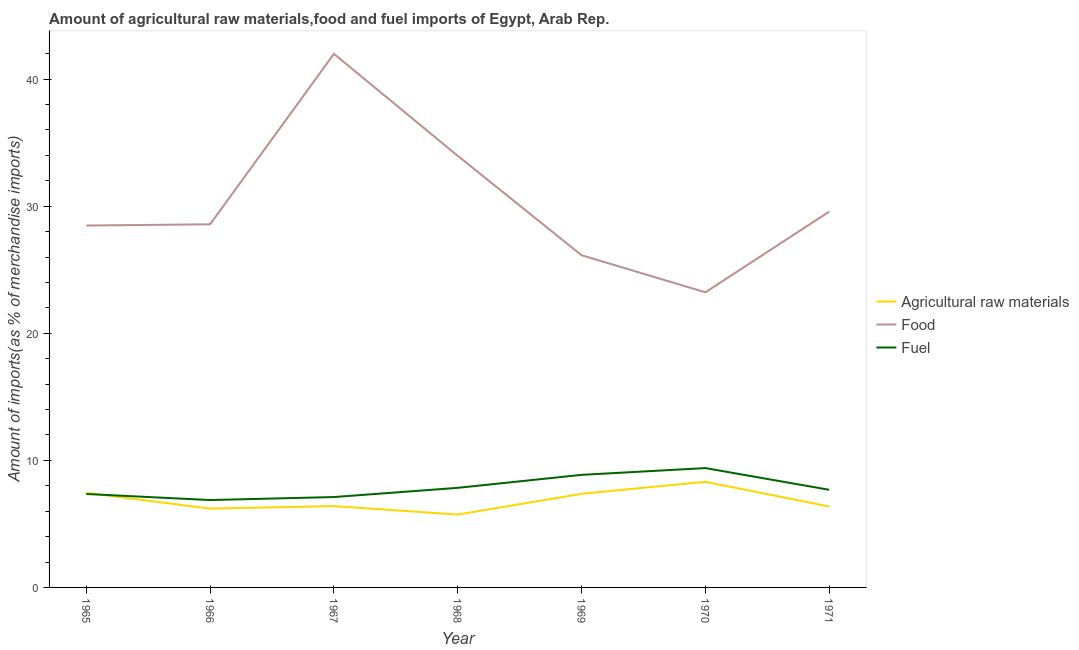How many different coloured lines are there?
Offer a terse response. 3. What is the percentage of fuel imports in 1969?
Provide a short and direct response. 8.86. Across all years, what is the maximum percentage of fuel imports?
Ensure brevity in your answer.  9.39. Across all years, what is the minimum percentage of raw materials imports?
Offer a terse response. 5.73. In which year was the percentage of raw materials imports minimum?
Ensure brevity in your answer.  1968. What is the total percentage of raw materials imports in the graph?
Provide a short and direct response. 47.83. What is the difference between the percentage of raw materials imports in 1966 and that in 1967?
Keep it short and to the point. -0.2. What is the difference between the percentage of raw materials imports in 1971 and the percentage of fuel imports in 1968?
Provide a succinct answer. -1.47. What is the average percentage of raw materials imports per year?
Keep it short and to the point. 6.83. In the year 1968, what is the difference between the percentage of food imports and percentage of raw materials imports?
Ensure brevity in your answer.  28.23. What is the ratio of the percentage of food imports in 1966 to that in 1968?
Give a very brief answer. 0.84. Is the difference between the percentage of raw materials imports in 1967 and 1970 greater than the difference between the percentage of fuel imports in 1967 and 1970?
Provide a succinct answer. Yes. What is the difference between the highest and the second highest percentage of food imports?
Make the answer very short. 8.03. What is the difference between the highest and the lowest percentage of fuel imports?
Give a very brief answer. 2.51. In how many years, is the percentage of food imports greater than the average percentage of food imports taken over all years?
Your answer should be very brief. 2. Is it the case that in every year, the sum of the percentage of raw materials imports and percentage of food imports is greater than the percentage of fuel imports?
Give a very brief answer. Yes. Does the percentage of fuel imports monotonically increase over the years?
Offer a terse response. No. Is the percentage of food imports strictly greater than the percentage of fuel imports over the years?
Your response must be concise. Yes. Is the percentage of fuel imports strictly less than the percentage of food imports over the years?
Your answer should be compact. Yes. How many lines are there?
Keep it short and to the point. 3. What is the difference between two consecutive major ticks on the Y-axis?
Your response must be concise. 10. Are the values on the major ticks of Y-axis written in scientific E-notation?
Give a very brief answer. No. Does the graph contain any zero values?
Make the answer very short. No. How many legend labels are there?
Offer a very short reply. 3. What is the title of the graph?
Ensure brevity in your answer.  Amount of agricultural raw materials,food and fuel imports of Egypt, Arab Rep. Does "Social Protection and Labor" appear as one of the legend labels in the graph?
Your answer should be very brief. No. What is the label or title of the X-axis?
Offer a very short reply. Year. What is the label or title of the Y-axis?
Your answer should be very brief. Amount of imports(as % of merchandise imports). What is the Amount of imports(as % of merchandise imports) of Agricultural raw materials in 1965?
Your response must be concise. 7.44. What is the Amount of imports(as % of merchandise imports) in Food in 1965?
Your response must be concise. 28.48. What is the Amount of imports(as % of merchandise imports) of Fuel in 1965?
Offer a very short reply. 7.35. What is the Amount of imports(as % of merchandise imports) in Agricultural raw materials in 1966?
Your response must be concise. 6.2. What is the Amount of imports(as % of merchandise imports) in Food in 1966?
Your answer should be very brief. 28.58. What is the Amount of imports(as % of merchandise imports) of Fuel in 1966?
Offer a terse response. 6.88. What is the Amount of imports(as % of merchandise imports) in Agricultural raw materials in 1967?
Make the answer very short. 6.4. What is the Amount of imports(as % of merchandise imports) in Food in 1967?
Provide a succinct answer. 41.99. What is the Amount of imports(as % of merchandise imports) of Fuel in 1967?
Provide a succinct answer. 7.11. What is the Amount of imports(as % of merchandise imports) in Agricultural raw materials in 1968?
Make the answer very short. 5.73. What is the Amount of imports(as % of merchandise imports) in Food in 1968?
Your answer should be compact. 33.96. What is the Amount of imports(as % of merchandise imports) of Fuel in 1968?
Keep it short and to the point. 7.84. What is the Amount of imports(as % of merchandise imports) of Agricultural raw materials in 1969?
Your response must be concise. 7.37. What is the Amount of imports(as % of merchandise imports) of Food in 1969?
Keep it short and to the point. 26.14. What is the Amount of imports(as % of merchandise imports) in Fuel in 1969?
Offer a very short reply. 8.86. What is the Amount of imports(as % of merchandise imports) in Agricultural raw materials in 1970?
Keep it short and to the point. 8.31. What is the Amount of imports(as % of merchandise imports) in Food in 1970?
Give a very brief answer. 23.22. What is the Amount of imports(as % of merchandise imports) in Fuel in 1970?
Make the answer very short. 9.39. What is the Amount of imports(as % of merchandise imports) of Agricultural raw materials in 1971?
Offer a very short reply. 6.37. What is the Amount of imports(as % of merchandise imports) of Food in 1971?
Your answer should be very brief. 29.57. What is the Amount of imports(as % of merchandise imports) of Fuel in 1971?
Provide a succinct answer. 7.68. Across all years, what is the maximum Amount of imports(as % of merchandise imports) of Agricultural raw materials?
Provide a succinct answer. 8.31. Across all years, what is the maximum Amount of imports(as % of merchandise imports) of Food?
Provide a short and direct response. 41.99. Across all years, what is the maximum Amount of imports(as % of merchandise imports) in Fuel?
Give a very brief answer. 9.39. Across all years, what is the minimum Amount of imports(as % of merchandise imports) of Agricultural raw materials?
Your response must be concise. 5.73. Across all years, what is the minimum Amount of imports(as % of merchandise imports) in Food?
Provide a short and direct response. 23.22. Across all years, what is the minimum Amount of imports(as % of merchandise imports) of Fuel?
Offer a terse response. 6.88. What is the total Amount of imports(as % of merchandise imports) in Agricultural raw materials in the graph?
Provide a short and direct response. 47.83. What is the total Amount of imports(as % of merchandise imports) of Food in the graph?
Give a very brief answer. 211.94. What is the total Amount of imports(as % of merchandise imports) of Fuel in the graph?
Ensure brevity in your answer.  55.11. What is the difference between the Amount of imports(as % of merchandise imports) in Agricultural raw materials in 1965 and that in 1966?
Offer a terse response. 1.24. What is the difference between the Amount of imports(as % of merchandise imports) in Food in 1965 and that in 1966?
Keep it short and to the point. -0.1. What is the difference between the Amount of imports(as % of merchandise imports) of Fuel in 1965 and that in 1966?
Ensure brevity in your answer.  0.48. What is the difference between the Amount of imports(as % of merchandise imports) of Agricultural raw materials in 1965 and that in 1967?
Ensure brevity in your answer.  1.04. What is the difference between the Amount of imports(as % of merchandise imports) in Food in 1965 and that in 1967?
Make the answer very short. -13.51. What is the difference between the Amount of imports(as % of merchandise imports) of Fuel in 1965 and that in 1967?
Offer a terse response. 0.24. What is the difference between the Amount of imports(as % of merchandise imports) in Agricultural raw materials in 1965 and that in 1968?
Provide a short and direct response. 1.71. What is the difference between the Amount of imports(as % of merchandise imports) in Food in 1965 and that in 1968?
Your response must be concise. -5.48. What is the difference between the Amount of imports(as % of merchandise imports) of Fuel in 1965 and that in 1968?
Provide a succinct answer. -0.48. What is the difference between the Amount of imports(as % of merchandise imports) of Agricultural raw materials in 1965 and that in 1969?
Your answer should be very brief. 0.08. What is the difference between the Amount of imports(as % of merchandise imports) of Food in 1965 and that in 1969?
Offer a terse response. 2.34. What is the difference between the Amount of imports(as % of merchandise imports) of Fuel in 1965 and that in 1969?
Your answer should be compact. -1.51. What is the difference between the Amount of imports(as % of merchandise imports) of Agricultural raw materials in 1965 and that in 1970?
Provide a succinct answer. -0.87. What is the difference between the Amount of imports(as % of merchandise imports) of Food in 1965 and that in 1970?
Offer a very short reply. 5.25. What is the difference between the Amount of imports(as % of merchandise imports) of Fuel in 1965 and that in 1970?
Make the answer very short. -2.04. What is the difference between the Amount of imports(as % of merchandise imports) in Agricultural raw materials in 1965 and that in 1971?
Offer a terse response. 1.07. What is the difference between the Amount of imports(as % of merchandise imports) in Food in 1965 and that in 1971?
Offer a very short reply. -1.1. What is the difference between the Amount of imports(as % of merchandise imports) of Fuel in 1965 and that in 1971?
Offer a terse response. -0.33. What is the difference between the Amount of imports(as % of merchandise imports) in Agricultural raw materials in 1966 and that in 1967?
Your response must be concise. -0.2. What is the difference between the Amount of imports(as % of merchandise imports) of Food in 1966 and that in 1967?
Provide a short and direct response. -13.41. What is the difference between the Amount of imports(as % of merchandise imports) in Fuel in 1966 and that in 1967?
Your response must be concise. -0.24. What is the difference between the Amount of imports(as % of merchandise imports) of Agricultural raw materials in 1966 and that in 1968?
Your response must be concise. 0.47. What is the difference between the Amount of imports(as % of merchandise imports) in Food in 1966 and that in 1968?
Keep it short and to the point. -5.39. What is the difference between the Amount of imports(as % of merchandise imports) of Fuel in 1966 and that in 1968?
Ensure brevity in your answer.  -0.96. What is the difference between the Amount of imports(as % of merchandise imports) of Agricultural raw materials in 1966 and that in 1969?
Make the answer very short. -1.16. What is the difference between the Amount of imports(as % of merchandise imports) of Food in 1966 and that in 1969?
Ensure brevity in your answer.  2.43. What is the difference between the Amount of imports(as % of merchandise imports) of Fuel in 1966 and that in 1969?
Keep it short and to the point. -1.98. What is the difference between the Amount of imports(as % of merchandise imports) of Agricultural raw materials in 1966 and that in 1970?
Offer a very short reply. -2.11. What is the difference between the Amount of imports(as % of merchandise imports) of Food in 1966 and that in 1970?
Your response must be concise. 5.35. What is the difference between the Amount of imports(as % of merchandise imports) of Fuel in 1966 and that in 1970?
Offer a terse response. -2.51. What is the difference between the Amount of imports(as % of merchandise imports) of Agricultural raw materials in 1966 and that in 1971?
Make the answer very short. -0.17. What is the difference between the Amount of imports(as % of merchandise imports) in Food in 1966 and that in 1971?
Provide a succinct answer. -1. What is the difference between the Amount of imports(as % of merchandise imports) of Fuel in 1966 and that in 1971?
Give a very brief answer. -0.81. What is the difference between the Amount of imports(as % of merchandise imports) in Agricultural raw materials in 1967 and that in 1968?
Your response must be concise. 0.67. What is the difference between the Amount of imports(as % of merchandise imports) in Food in 1967 and that in 1968?
Give a very brief answer. 8.03. What is the difference between the Amount of imports(as % of merchandise imports) in Fuel in 1967 and that in 1968?
Provide a short and direct response. -0.72. What is the difference between the Amount of imports(as % of merchandise imports) in Agricultural raw materials in 1967 and that in 1969?
Provide a succinct answer. -0.97. What is the difference between the Amount of imports(as % of merchandise imports) of Food in 1967 and that in 1969?
Keep it short and to the point. 15.85. What is the difference between the Amount of imports(as % of merchandise imports) of Fuel in 1967 and that in 1969?
Your answer should be compact. -1.75. What is the difference between the Amount of imports(as % of merchandise imports) in Agricultural raw materials in 1967 and that in 1970?
Provide a succinct answer. -1.91. What is the difference between the Amount of imports(as % of merchandise imports) of Food in 1967 and that in 1970?
Your answer should be very brief. 18.76. What is the difference between the Amount of imports(as % of merchandise imports) in Fuel in 1967 and that in 1970?
Your response must be concise. -2.28. What is the difference between the Amount of imports(as % of merchandise imports) in Agricultural raw materials in 1967 and that in 1971?
Keep it short and to the point. 0.03. What is the difference between the Amount of imports(as % of merchandise imports) of Food in 1967 and that in 1971?
Keep it short and to the point. 12.41. What is the difference between the Amount of imports(as % of merchandise imports) of Fuel in 1967 and that in 1971?
Make the answer very short. -0.57. What is the difference between the Amount of imports(as % of merchandise imports) in Agricultural raw materials in 1968 and that in 1969?
Provide a succinct answer. -1.63. What is the difference between the Amount of imports(as % of merchandise imports) in Food in 1968 and that in 1969?
Provide a short and direct response. 7.82. What is the difference between the Amount of imports(as % of merchandise imports) of Fuel in 1968 and that in 1969?
Your response must be concise. -1.02. What is the difference between the Amount of imports(as % of merchandise imports) in Agricultural raw materials in 1968 and that in 1970?
Ensure brevity in your answer.  -2.58. What is the difference between the Amount of imports(as % of merchandise imports) of Food in 1968 and that in 1970?
Give a very brief answer. 10.74. What is the difference between the Amount of imports(as % of merchandise imports) of Fuel in 1968 and that in 1970?
Your answer should be compact. -1.55. What is the difference between the Amount of imports(as % of merchandise imports) of Agricultural raw materials in 1968 and that in 1971?
Offer a very short reply. -0.64. What is the difference between the Amount of imports(as % of merchandise imports) of Food in 1968 and that in 1971?
Provide a succinct answer. 4.39. What is the difference between the Amount of imports(as % of merchandise imports) in Fuel in 1968 and that in 1971?
Keep it short and to the point. 0.15. What is the difference between the Amount of imports(as % of merchandise imports) of Agricultural raw materials in 1969 and that in 1970?
Provide a succinct answer. -0.95. What is the difference between the Amount of imports(as % of merchandise imports) of Food in 1969 and that in 1970?
Provide a succinct answer. 2.92. What is the difference between the Amount of imports(as % of merchandise imports) in Fuel in 1969 and that in 1970?
Ensure brevity in your answer.  -0.53. What is the difference between the Amount of imports(as % of merchandise imports) in Food in 1969 and that in 1971?
Keep it short and to the point. -3.43. What is the difference between the Amount of imports(as % of merchandise imports) of Fuel in 1969 and that in 1971?
Your answer should be very brief. 1.18. What is the difference between the Amount of imports(as % of merchandise imports) in Agricultural raw materials in 1970 and that in 1971?
Ensure brevity in your answer.  1.94. What is the difference between the Amount of imports(as % of merchandise imports) in Food in 1970 and that in 1971?
Keep it short and to the point. -6.35. What is the difference between the Amount of imports(as % of merchandise imports) of Fuel in 1970 and that in 1971?
Your answer should be compact. 1.71. What is the difference between the Amount of imports(as % of merchandise imports) of Agricultural raw materials in 1965 and the Amount of imports(as % of merchandise imports) of Food in 1966?
Provide a succinct answer. -21.13. What is the difference between the Amount of imports(as % of merchandise imports) of Agricultural raw materials in 1965 and the Amount of imports(as % of merchandise imports) of Fuel in 1966?
Offer a terse response. 0.57. What is the difference between the Amount of imports(as % of merchandise imports) in Food in 1965 and the Amount of imports(as % of merchandise imports) in Fuel in 1966?
Give a very brief answer. 21.6. What is the difference between the Amount of imports(as % of merchandise imports) of Agricultural raw materials in 1965 and the Amount of imports(as % of merchandise imports) of Food in 1967?
Make the answer very short. -34.55. What is the difference between the Amount of imports(as % of merchandise imports) in Agricultural raw materials in 1965 and the Amount of imports(as % of merchandise imports) in Fuel in 1967?
Keep it short and to the point. 0.33. What is the difference between the Amount of imports(as % of merchandise imports) in Food in 1965 and the Amount of imports(as % of merchandise imports) in Fuel in 1967?
Your response must be concise. 21.36. What is the difference between the Amount of imports(as % of merchandise imports) of Agricultural raw materials in 1965 and the Amount of imports(as % of merchandise imports) of Food in 1968?
Offer a very short reply. -26.52. What is the difference between the Amount of imports(as % of merchandise imports) of Agricultural raw materials in 1965 and the Amount of imports(as % of merchandise imports) of Fuel in 1968?
Your answer should be compact. -0.39. What is the difference between the Amount of imports(as % of merchandise imports) in Food in 1965 and the Amount of imports(as % of merchandise imports) in Fuel in 1968?
Provide a succinct answer. 20.64. What is the difference between the Amount of imports(as % of merchandise imports) of Agricultural raw materials in 1965 and the Amount of imports(as % of merchandise imports) of Food in 1969?
Provide a short and direct response. -18.7. What is the difference between the Amount of imports(as % of merchandise imports) of Agricultural raw materials in 1965 and the Amount of imports(as % of merchandise imports) of Fuel in 1969?
Ensure brevity in your answer.  -1.42. What is the difference between the Amount of imports(as % of merchandise imports) of Food in 1965 and the Amount of imports(as % of merchandise imports) of Fuel in 1969?
Offer a terse response. 19.62. What is the difference between the Amount of imports(as % of merchandise imports) of Agricultural raw materials in 1965 and the Amount of imports(as % of merchandise imports) of Food in 1970?
Ensure brevity in your answer.  -15.78. What is the difference between the Amount of imports(as % of merchandise imports) in Agricultural raw materials in 1965 and the Amount of imports(as % of merchandise imports) in Fuel in 1970?
Your answer should be very brief. -1.95. What is the difference between the Amount of imports(as % of merchandise imports) of Food in 1965 and the Amount of imports(as % of merchandise imports) of Fuel in 1970?
Your answer should be very brief. 19.09. What is the difference between the Amount of imports(as % of merchandise imports) of Agricultural raw materials in 1965 and the Amount of imports(as % of merchandise imports) of Food in 1971?
Your answer should be very brief. -22.13. What is the difference between the Amount of imports(as % of merchandise imports) in Agricultural raw materials in 1965 and the Amount of imports(as % of merchandise imports) in Fuel in 1971?
Give a very brief answer. -0.24. What is the difference between the Amount of imports(as % of merchandise imports) in Food in 1965 and the Amount of imports(as % of merchandise imports) in Fuel in 1971?
Provide a short and direct response. 20.8. What is the difference between the Amount of imports(as % of merchandise imports) of Agricultural raw materials in 1966 and the Amount of imports(as % of merchandise imports) of Food in 1967?
Offer a terse response. -35.79. What is the difference between the Amount of imports(as % of merchandise imports) in Agricultural raw materials in 1966 and the Amount of imports(as % of merchandise imports) in Fuel in 1967?
Make the answer very short. -0.91. What is the difference between the Amount of imports(as % of merchandise imports) of Food in 1966 and the Amount of imports(as % of merchandise imports) of Fuel in 1967?
Ensure brevity in your answer.  21.46. What is the difference between the Amount of imports(as % of merchandise imports) in Agricultural raw materials in 1966 and the Amount of imports(as % of merchandise imports) in Food in 1968?
Your response must be concise. -27.76. What is the difference between the Amount of imports(as % of merchandise imports) of Agricultural raw materials in 1966 and the Amount of imports(as % of merchandise imports) of Fuel in 1968?
Your answer should be very brief. -1.63. What is the difference between the Amount of imports(as % of merchandise imports) in Food in 1966 and the Amount of imports(as % of merchandise imports) in Fuel in 1968?
Provide a short and direct response. 20.74. What is the difference between the Amount of imports(as % of merchandise imports) in Agricultural raw materials in 1966 and the Amount of imports(as % of merchandise imports) in Food in 1969?
Give a very brief answer. -19.94. What is the difference between the Amount of imports(as % of merchandise imports) of Agricultural raw materials in 1966 and the Amount of imports(as % of merchandise imports) of Fuel in 1969?
Provide a succinct answer. -2.66. What is the difference between the Amount of imports(as % of merchandise imports) in Food in 1966 and the Amount of imports(as % of merchandise imports) in Fuel in 1969?
Your answer should be very brief. 19.72. What is the difference between the Amount of imports(as % of merchandise imports) of Agricultural raw materials in 1966 and the Amount of imports(as % of merchandise imports) of Food in 1970?
Offer a very short reply. -17.02. What is the difference between the Amount of imports(as % of merchandise imports) of Agricultural raw materials in 1966 and the Amount of imports(as % of merchandise imports) of Fuel in 1970?
Give a very brief answer. -3.19. What is the difference between the Amount of imports(as % of merchandise imports) in Food in 1966 and the Amount of imports(as % of merchandise imports) in Fuel in 1970?
Give a very brief answer. 19.19. What is the difference between the Amount of imports(as % of merchandise imports) of Agricultural raw materials in 1966 and the Amount of imports(as % of merchandise imports) of Food in 1971?
Ensure brevity in your answer.  -23.37. What is the difference between the Amount of imports(as % of merchandise imports) of Agricultural raw materials in 1966 and the Amount of imports(as % of merchandise imports) of Fuel in 1971?
Provide a short and direct response. -1.48. What is the difference between the Amount of imports(as % of merchandise imports) in Food in 1966 and the Amount of imports(as % of merchandise imports) in Fuel in 1971?
Ensure brevity in your answer.  20.89. What is the difference between the Amount of imports(as % of merchandise imports) of Agricultural raw materials in 1967 and the Amount of imports(as % of merchandise imports) of Food in 1968?
Make the answer very short. -27.56. What is the difference between the Amount of imports(as % of merchandise imports) in Agricultural raw materials in 1967 and the Amount of imports(as % of merchandise imports) in Fuel in 1968?
Keep it short and to the point. -1.44. What is the difference between the Amount of imports(as % of merchandise imports) of Food in 1967 and the Amount of imports(as % of merchandise imports) of Fuel in 1968?
Keep it short and to the point. 34.15. What is the difference between the Amount of imports(as % of merchandise imports) of Agricultural raw materials in 1967 and the Amount of imports(as % of merchandise imports) of Food in 1969?
Your answer should be compact. -19.74. What is the difference between the Amount of imports(as % of merchandise imports) of Agricultural raw materials in 1967 and the Amount of imports(as % of merchandise imports) of Fuel in 1969?
Offer a very short reply. -2.46. What is the difference between the Amount of imports(as % of merchandise imports) in Food in 1967 and the Amount of imports(as % of merchandise imports) in Fuel in 1969?
Offer a very short reply. 33.13. What is the difference between the Amount of imports(as % of merchandise imports) in Agricultural raw materials in 1967 and the Amount of imports(as % of merchandise imports) in Food in 1970?
Offer a terse response. -16.82. What is the difference between the Amount of imports(as % of merchandise imports) in Agricultural raw materials in 1967 and the Amount of imports(as % of merchandise imports) in Fuel in 1970?
Make the answer very short. -2.99. What is the difference between the Amount of imports(as % of merchandise imports) in Food in 1967 and the Amount of imports(as % of merchandise imports) in Fuel in 1970?
Your answer should be very brief. 32.6. What is the difference between the Amount of imports(as % of merchandise imports) of Agricultural raw materials in 1967 and the Amount of imports(as % of merchandise imports) of Food in 1971?
Your response must be concise. -23.17. What is the difference between the Amount of imports(as % of merchandise imports) in Agricultural raw materials in 1967 and the Amount of imports(as % of merchandise imports) in Fuel in 1971?
Keep it short and to the point. -1.28. What is the difference between the Amount of imports(as % of merchandise imports) of Food in 1967 and the Amount of imports(as % of merchandise imports) of Fuel in 1971?
Make the answer very short. 34.31. What is the difference between the Amount of imports(as % of merchandise imports) of Agricultural raw materials in 1968 and the Amount of imports(as % of merchandise imports) of Food in 1969?
Offer a terse response. -20.41. What is the difference between the Amount of imports(as % of merchandise imports) of Agricultural raw materials in 1968 and the Amount of imports(as % of merchandise imports) of Fuel in 1969?
Offer a very short reply. -3.13. What is the difference between the Amount of imports(as % of merchandise imports) in Food in 1968 and the Amount of imports(as % of merchandise imports) in Fuel in 1969?
Give a very brief answer. 25.1. What is the difference between the Amount of imports(as % of merchandise imports) of Agricultural raw materials in 1968 and the Amount of imports(as % of merchandise imports) of Food in 1970?
Offer a terse response. -17.49. What is the difference between the Amount of imports(as % of merchandise imports) in Agricultural raw materials in 1968 and the Amount of imports(as % of merchandise imports) in Fuel in 1970?
Your answer should be very brief. -3.66. What is the difference between the Amount of imports(as % of merchandise imports) of Food in 1968 and the Amount of imports(as % of merchandise imports) of Fuel in 1970?
Provide a short and direct response. 24.57. What is the difference between the Amount of imports(as % of merchandise imports) of Agricultural raw materials in 1968 and the Amount of imports(as % of merchandise imports) of Food in 1971?
Give a very brief answer. -23.84. What is the difference between the Amount of imports(as % of merchandise imports) in Agricultural raw materials in 1968 and the Amount of imports(as % of merchandise imports) in Fuel in 1971?
Ensure brevity in your answer.  -1.95. What is the difference between the Amount of imports(as % of merchandise imports) of Food in 1968 and the Amount of imports(as % of merchandise imports) of Fuel in 1971?
Offer a very short reply. 26.28. What is the difference between the Amount of imports(as % of merchandise imports) in Agricultural raw materials in 1969 and the Amount of imports(as % of merchandise imports) in Food in 1970?
Offer a terse response. -15.86. What is the difference between the Amount of imports(as % of merchandise imports) in Agricultural raw materials in 1969 and the Amount of imports(as % of merchandise imports) in Fuel in 1970?
Make the answer very short. -2.02. What is the difference between the Amount of imports(as % of merchandise imports) of Food in 1969 and the Amount of imports(as % of merchandise imports) of Fuel in 1970?
Make the answer very short. 16.75. What is the difference between the Amount of imports(as % of merchandise imports) of Agricultural raw materials in 1969 and the Amount of imports(as % of merchandise imports) of Food in 1971?
Ensure brevity in your answer.  -22.21. What is the difference between the Amount of imports(as % of merchandise imports) in Agricultural raw materials in 1969 and the Amount of imports(as % of merchandise imports) in Fuel in 1971?
Your response must be concise. -0.32. What is the difference between the Amount of imports(as % of merchandise imports) of Food in 1969 and the Amount of imports(as % of merchandise imports) of Fuel in 1971?
Give a very brief answer. 18.46. What is the difference between the Amount of imports(as % of merchandise imports) of Agricultural raw materials in 1970 and the Amount of imports(as % of merchandise imports) of Food in 1971?
Ensure brevity in your answer.  -21.26. What is the difference between the Amount of imports(as % of merchandise imports) of Agricultural raw materials in 1970 and the Amount of imports(as % of merchandise imports) of Fuel in 1971?
Give a very brief answer. 0.63. What is the difference between the Amount of imports(as % of merchandise imports) in Food in 1970 and the Amount of imports(as % of merchandise imports) in Fuel in 1971?
Your response must be concise. 15.54. What is the average Amount of imports(as % of merchandise imports) in Agricultural raw materials per year?
Your answer should be very brief. 6.83. What is the average Amount of imports(as % of merchandise imports) in Food per year?
Give a very brief answer. 30.28. What is the average Amount of imports(as % of merchandise imports) in Fuel per year?
Offer a terse response. 7.87. In the year 1965, what is the difference between the Amount of imports(as % of merchandise imports) in Agricultural raw materials and Amount of imports(as % of merchandise imports) in Food?
Provide a short and direct response. -21.04. In the year 1965, what is the difference between the Amount of imports(as % of merchandise imports) in Agricultural raw materials and Amount of imports(as % of merchandise imports) in Fuel?
Your answer should be compact. 0.09. In the year 1965, what is the difference between the Amount of imports(as % of merchandise imports) of Food and Amount of imports(as % of merchandise imports) of Fuel?
Your response must be concise. 21.13. In the year 1966, what is the difference between the Amount of imports(as % of merchandise imports) in Agricultural raw materials and Amount of imports(as % of merchandise imports) in Food?
Offer a very short reply. -22.37. In the year 1966, what is the difference between the Amount of imports(as % of merchandise imports) of Agricultural raw materials and Amount of imports(as % of merchandise imports) of Fuel?
Keep it short and to the point. -0.67. In the year 1966, what is the difference between the Amount of imports(as % of merchandise imports) of Food and Amount of imports(as % of merchandise imports) of Fuel?
Your response must be concise. 21.7. In the year 1967, what is the difference between the Amount of imports(as % of merchandise imports) in Agricultural raw materials and Amount of imports(as % of merchandise imports) in Food?
Provide a succinct answer. -35.59. In the year 1967, what is the difference between the Amount of imports(as % of merchandise imports) in Agricultural raw materials and Amount of imports(as % of merchandise imports) in Fuel?
Offer a very short reply. -0.71. In the year 1967, what is the difference between the Amount of imports(as % of merchandise imports) in Food and Amount of imports(as % of merchandise imports) in Fuel?
Keep it short and to the point. 34.88. In the year 1968, what is the difference between the Amount of imports(as % of merchandise imports) in Agricultural raw materials and Amount of imports(as % of merchandise imports) in Food?
Your response must be concise. -28.23. In the year 1968, what is the difference between the Amount of imports(as % of merchandise imports) of Agricultural raw materials and Amount of imports(as % of merchandise imports) of Fuel?
Provide a short and direct response. -2.1. In the year 1968, what is the difference between the Amount of imports(as % of merchandise imports) of Food and Amount of imports(as % of merchandise imports) of Fuel?
Your answer should be very brief. 26.13. In the year 1969, what is the difference between the Amount of imports(as % of merchandise imports) of Agricultural raw materials and Amount of imports(as % of merchandise imports) of Food?
Your answer should be very brief. -18.78. In the year 1969, what is the difference between the Amount of imports(as % of merchandise imports) in Agricultural raw materials and Amount of imports(as % of merchandise imports) in Fuel?
Make the answer very short. -1.49. In the year 1969, what is the difference between the Amount of imports(as % of merchandise imports) of Food and Amount of imports(as % of merchandise imports) of Fuel?
Give a very brief answer. 17.28. In the year 1970, what is the difference between the Amount of imports(as % of merchandise imports) of Agricultural raw materials and Amount of imports(as % of merchandise imports) of Food?
Keep it short and to the point. -14.91. In the year 1970, what is the difference between the Amount of imports(as % of merchandise imports) of Agricultural raw materials and Amount of imports(as % of merchandise imports) of Fuel?
Give a very brief answer. -1.08. In the year 1970, what is the difference between the Amount of imports(as % of merchandise imports) in Food and Amount of imports(as % of merchandise imports) in Fuel?
Keep it short and to the point. 13.83. In the year 1971, what is the difference between the Amount of imports(as % of merchandise imports) of Agricultural raw materials and Amount of imports(as % of merchandise imports) of Food?
Your answer should be very brief. -23.2. In the year 1971, what is the difference between the Amount of imports(as % of merchandise imports) of Agricultural raw materials and Amount of imports(as % of merchandise imports) of Fuel?
Offer a very short reply. -1.31. In the year 1971, what is the difference between the Amount of imports(as % of merchandise imports) in Food and Amount of imports(as % of merchandise imports) in Fuel?
Offer a terse response. 21.89. What is the ratio of the Amount of imports(as % of merchandise imports) in Agricultural raw materials in 1965 to that in 1966?
Give a very brief answer. 1.2. What is the ratio of the Amount of imports(as % of merchandise imports) in Fuel in 1965 to that in 1966?
Ensure brevity in your answer.  1.07. What is the ratio of the Amount of imports(as % of merchandise imports) in Agricultural raw materials in 1965 to that in 1967?
Your answer should be very brief. 1.16. What is the ratio of the Amount of imports(as % of merchandise imports) of Food in 1965 to that in 1967?
Provide a succinct answer. 0.68. What is the ratio of the Amount of imports(as % of merchandise imports) of Fuel in 1965 to that in 1967?
Your answer should be very brief. 1.03. What is the ratio of the Amount of imports(as % of merchandise imports) in Agricultural raw materials in 1965 to that in 1968?
Provide a succinct answer. 1.3. What is the ratio of the Amount of imports(as % of merchandise imports) in Food in 1965 to that in 1968?
Offer a terse response. 0.84. What is the ratio of the Amount of imports(as % of merchandise imports) in Fuel in 1965 to that in 1968?
Your response must be concise. 0.94. What is the ratio of the Amount of imports(as % of merchandise imports) in Agricultural raw materials in 1965 to that in 1969?
Your response must be concise. 1.01. What is the ratio of the Amount of imports(as % of merchandise imports) of Food in 1965 to that in 1969?
Offer a terse response. 1.09. What is the ratio of the Amount of imports(as % of merchandise imports) of Fuel in 1965 to that in 1969?
Offer a terse response. 0.83. What is the ratio of the Amount of imports(as % of merchandise imports) in Agricultural raw materials in 1965 to that in 1970?
Your answer should be very brief. 0.9. What is the ratio of the Amount of imports(as % of merchandise imports) of Food in 1965 to that in 1970?
Keep it short and to the point. 1.23. What is the ratio of the Amount of imports(as % of merchandise imports) of Fuel in 1965 to that in 1970?
Provide a short and direct response. 0.78. What is the ratio of the Amount of imports(as % of merchandise imports) in Agricultural raw materials in 1965 to that in 1971?
Ensure brevity in your answer.  1.17. What is the ratio of the Amount of imports(as % of merchandise imports) in Food in 1965 to that in 1971?
Make the answer very short. 0.96. What is the ratio of the Amount of imports(as % of merchandise imports) of Fuel in 1965 to that in 1971?
Give a very brief answer. 0.96. What is the ratio of the Amount of imports(as % of merchandise imports) in Agricultural raw materials in 1966 to that in 1967?
Ensure brevity in your answer.  0.97. What is the ratio of the Amount of imports(as % of merchandise imports) in Food in 1966 to that in 1967?
Make the answer very short. 0.68. What is the ratio of the Amount of imports(as % of merchandise imports) in Fuel in 1966 to that in 1967?
Your response must be concise. 0.97. What is the ratio of the Amount of imports(as % of merchandise imports) in Agricultural raw materials in 1966 to that in 1968?
Give a very brief answer. 1.08. What is the ratio of the Amount of imports(as % of merchandise imports) of Food in 1966 to that in 1968?
Your answer should be very brief. 0.84. What is the ratio of the Amount of imports(as % of merchandise imports) in Fuel in 1966 to that in 1968?
Provide a short and direct response. 0.88. What is the ratio of the Amount of imports(as % of merchandise imports) in Agricultural raw materials in 1966 to that in 1969?
Ensure brevity in your answer.  0.84. What is the ratio of the Amount of imports(as % of merchandise imports) in Food in 1966 to that in 1969?
Offer a terse response. 1.09. What is the ratio of the Amount of imports(as % of merchandise imports) of Fuel in 1966 to that in 1969?
Provide a succinct answer. 0.78. What is the ratio of the Amount of imports(as % of merchandise imports) of Agricultural raw materials in 1966 to that in 1970?
Offer a very short reply. 0.75. What is the ratio of the Amount of imports(as % of merchandise imports) in Food in 1966 to that in 1970?
Give a very brief answer. 1.23. What is the ratio of the Amount of imports(as % of merchandise imports) of Fuel in 1966 to that in 1970?
Your answer should be very brief. 0.73. What is the ratio of the Amount of imports(as % of merchandise imports) of Agricultural raw materials in 1966 to that in 1971?
Provide a succinct answer. 0.97. What is the ratio of the Amount of imports(as % of merchandise imports) of Food in 1966 to that in 1971?
Offer a terse response. 0.97. What is the ratio of the Amount of imports(as % of merchandise imports) of Fuel in 1966 to that in 1971?
Your response must be concise. 0.9. What is the ratio of the Amount of imports(as % of merchandise imports) of Agricultural raw materials in 1967 to that in 1968?
Your response must be concise. 1.12. What is the ratio of the Amount of imports(as % of merchandise imports) in Food in 1967 to that in 1968?
Provide a short and direct response. 1.24. What is the ratio of the Amount of imports(as % of merchandise imports) of Fuel in 1967 to that in 1968?
Make the answer very short. 0.91. What is the ratio of the Amount of imports(as % of merchandise imports) of Agricultural raw materials in 1967 to that in 1969?
Ensure brevity in your answer.  0.87. What is the ratio of the Amount of imports(as % of merchandise imports) of Food in 1967 to that in 1969?
Your answer should be compact. 1.61. What is the ratio of the Amount of imports(as % of merchandise imports) in Fuel in 1967 to that in 1969?
Offer a very short reply. 0.8. What is the ratio of the Amount of imports(as % of merchandise imports) in Agricultural raw materials in 1967 to that in 1970?
Offer a very short reply. 0.77. What is the ratio of the Amount of imports(as % of merchandise imports) in Food in 1967 to that in 1970?
Keep it short and to the point. 1.81. What is the ratio of the Amount of imports(as % of merchandise imports) in Fuel in 1967 to that in 1970?
Your answer should be compact. 0.76. What is the ratio of the Amount of imports(as % of merchandise imports) of Food in 1967 to that in 1971?
Offer a terse response. 1.42. What is the ratio of the Amount of imports(as % of merchandise imports) of Fuel in 1967 to that in 1971?
Your response must be concise. 0.93. What is the ratio of the Amount of imports(as % of merchandise imports) of Agricultural raw materials in 1968 to that in 1969?
Provide a succinct answer. 0.78. What is the ratio of the Amount of imports(as % of merchandise imports) in Food in 1968 to that in 1969?
Your response must be concise. 1.3. What is the ratio of the Amount of imports(as % of merchandise imports) in Fuel in 1968 to that in 1969?
Give a very brief answer. 0.88. What is the ratio of the Amount of imports(as % of merchandise imports) of Agricultural raw materials in 1968 to that in 1970?
Your answer should be compact. 0.69. What is the ratio of the Amount of imports(as % of merchandise imports) of Food in 1968 to that in 1970?
Your answer should be very brief. 1.46. What is the ratio of the Amount of imports(as % of merchandise imports) of Fuel in 1968 to that in 1970?
Your answer should be compact. 0.83. What is the ratio of the Amount of imports(as % of merchandise imports) of Agricultural raw materials in 1968 to that in 1971?
Offer a very short reply. 0.9. What is the ratio of the Amount of imports(as % of merchandise imports) in Food in 1968 to that in 1971?
Give a very brief answer. 1.15. What is the ratio of the Amount of imports(as % of merchandise imports) in Fuel in 1968 to that in 1971?
Your response must be concise. 1.02. What is the ratio of the Amount of imports(as % of merchandise imports) in Agricultural raw materials in 1969 to that in 1970?
Your response must be concise. 0.89. What is the ratio of the Amount of imports(as % of merchandise imports) in Food in 1969 to that in 1970?
Your answer should be compact. 1.13. What is the ratio of the Amount of imports(as % of merchandise imports) in Fuel in 1969 to that in 1970?
Make the answer very short. 0.94. What is the ratio of the Amount of imports(as % of merchandise imports) of Agricultural raw materials in 1969 to that in 1971?
Keep it short and to the point. 1.16. What is the ratio of the Amount of imports(as % of merchandise imports) in Food in 1969 to that in 1971?
Give a very brief answer. 0.88. What is the ratio of the Amount of imports(as % of merchandise imports) in Fuel in 1969 to that in 1971?
Your answer should be very brief. 1.15. What is the ratio of the Amount of imports(as % of merchandise imports) in Agricultural raw materials in 1970 to that in 1971?
Make the answer very short. 1.31. What is the ratio of the Amount of imports(as % of merchandise imports) in Food in 1970 to that in 1971?
Ensure brevity in your answer.  0.79. What is the ratio of the Amount of imports(as % of merchandise imports) of Fuel in 1970 to that in 1971?
Keep it short and to the point. 1.22. What is the difference between the highest and the second highest Amount of imports(as % of merchandise imports) of Agricultural raw materials?
Provide a succinct answer. 0.87. What is the difference between the highest and the second highest Amount of imports(as % of merchandise imports) in Food?
Your answer should be compact. 8.03. What is the difference between the highest and the second highest Amount of imports(as % of merchandise imports) of Fuel?
Provide a short and direct response. 0.53. What is the difference between the highest and the lowest Amount of imports(as % of merchandise imports) of Agricultural raw materials?
Offer a terse response. 2.58. What is the difference between the highest and the lowest Amount of imports(as % of merchandise imports) of Food?
Provide a short and direct response. 18.76. What is the difference between the highest and the lowest Amount of imports(as % of merchandise imports) of Fuel?
Offer a terse response. 2.51. 